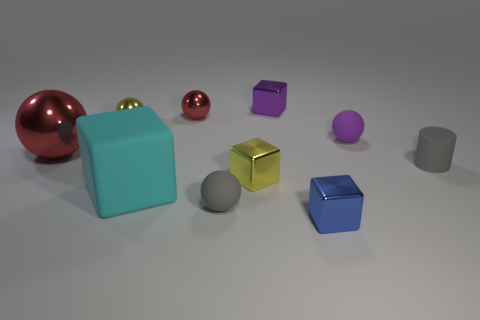There is a blue metal object that is the same size as the yellow metallic ball; what shape is it?
Your answer should be compact. Cube. There is a yellow metal ball; are there any gray matte objects on the left side of it?
Your answer should be very brief. No. There is a red metal thing on the left side of the yellow shiny ball; is there a blue metal block on the left side of it?
Offer a very short reply. No. Is the number of large cyan things that are to the right of the small blue shiny block less than the number of small matte spheres in front of the big red thing?
Provide a short and direct response. Yes. Is there any other thing that is the same size as the yellow metal block?
Keep it short and to the point. Yes. The large rubber object is what shape?
Your answer should be compact. Cube. There is a tiny yellow object that is behind the big metal sphere; what material is it?
Offer a terse response. Metal. There is a red metal ball in front of the small yellow metal thing that is behind the large red metallic sphere that is to the left of the tiny purple block; what size is it?
Provide a succinct answer. Large. Do the small yellow object in front of the big red ball and the small gray object in front of the matte block have the same material?
Provide a succinct answer. No. How many other objects are there of the same color as the large metallic sphere?
Provide a short and direct response. 1. 